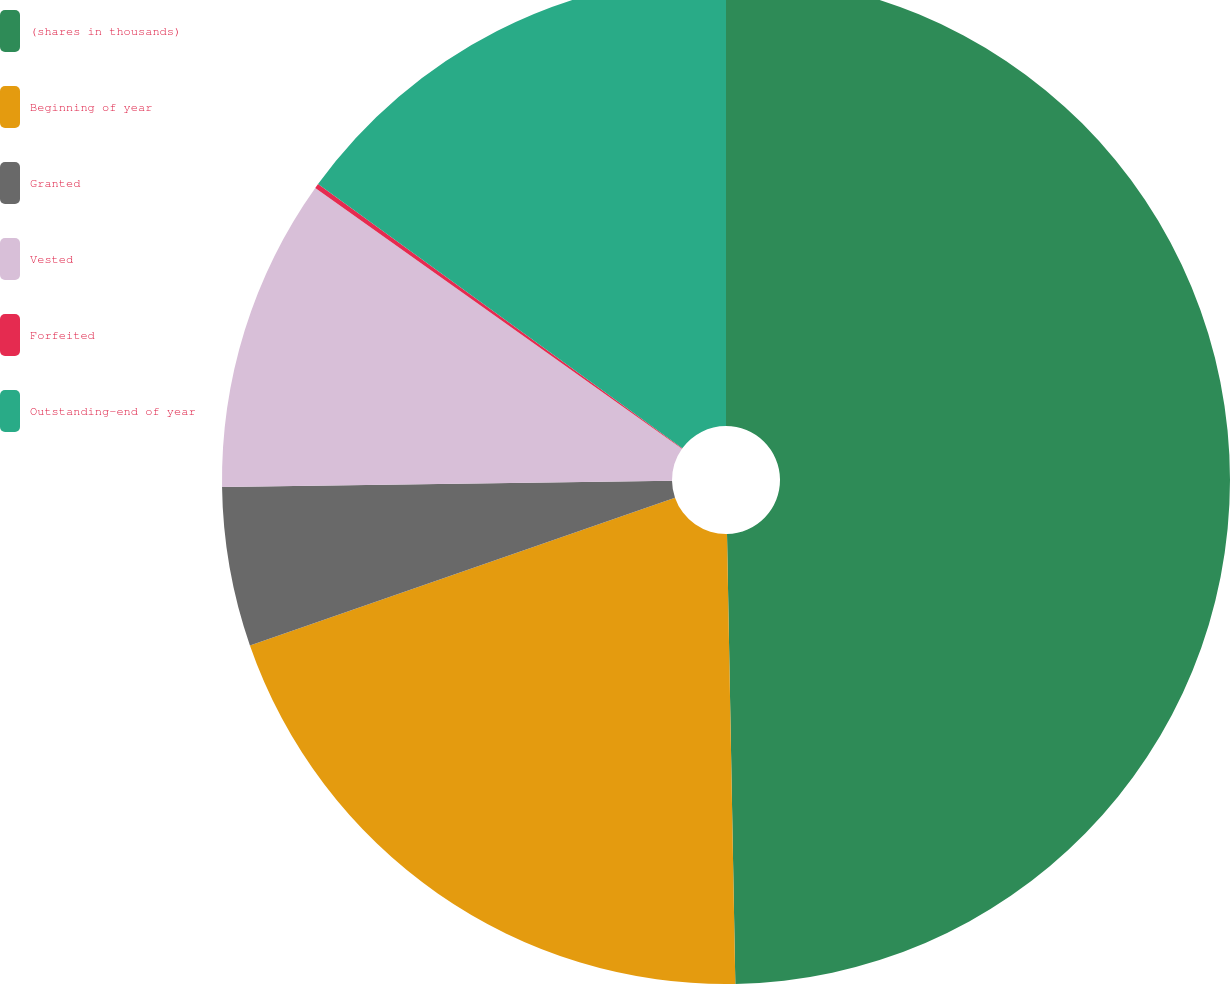<chart> <loc_0><loc_0><loc_500><loc_500><pie_chart><fcel>(shares in thousands)<fcel>Beginning of year<fcel>Granted<fcel>Vested<fcel>Forfeited<fcel>Outstanding-end of year<nl><fcel>49.7%<fcel>19.97%<fcel>5.1%<fcel>10.06%<fcel>0.15%<fcel>15.01%<nl></chart> 